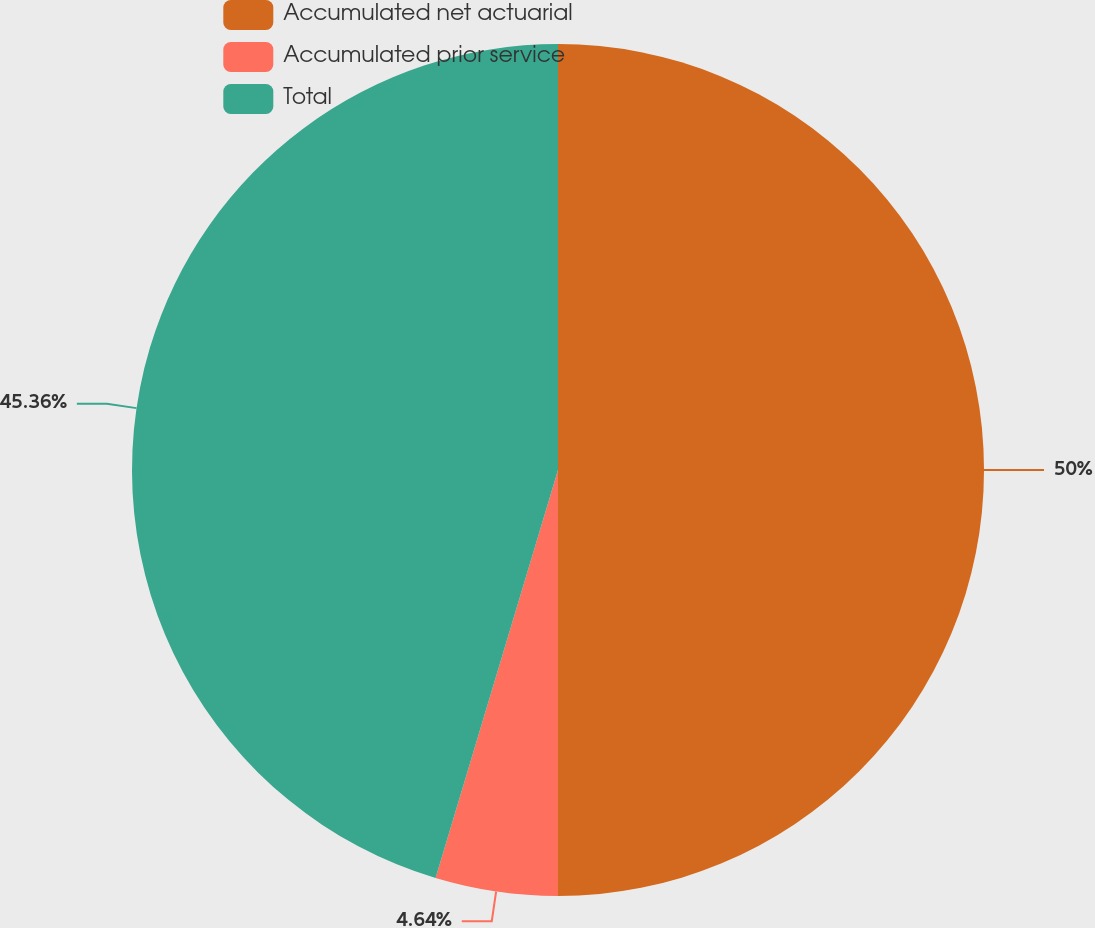Convert chart. <chart><loc_0><loc_0><loc_500><loc_500><pie_chart><fcel>Accumulated net actuarial<fcel>Accumulated prior service<fcel>Total<nl><fcel>50.0%<fcel>4.64%<fcel>45.36%<nl></chart> 